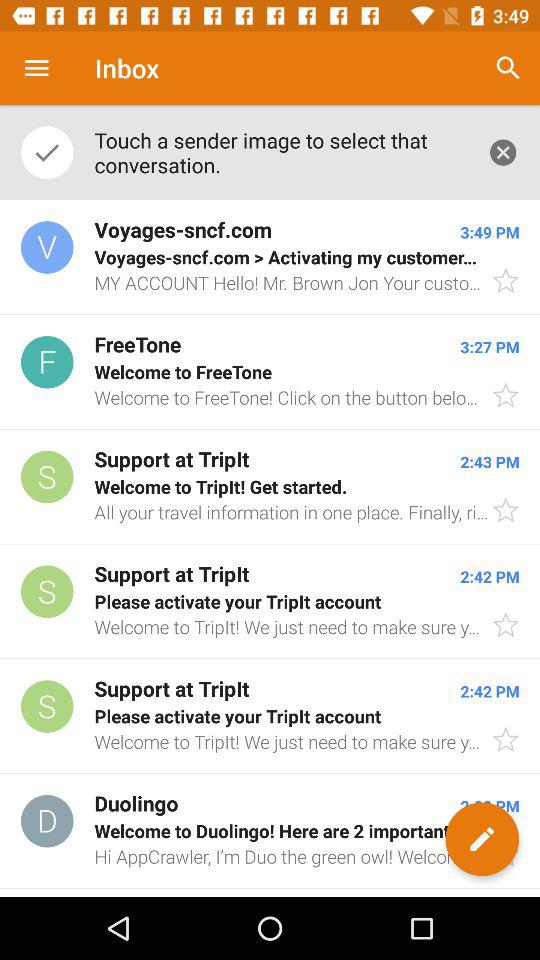At what time is mail received from voyages-sncf.com? The time is 3:49 PM. 